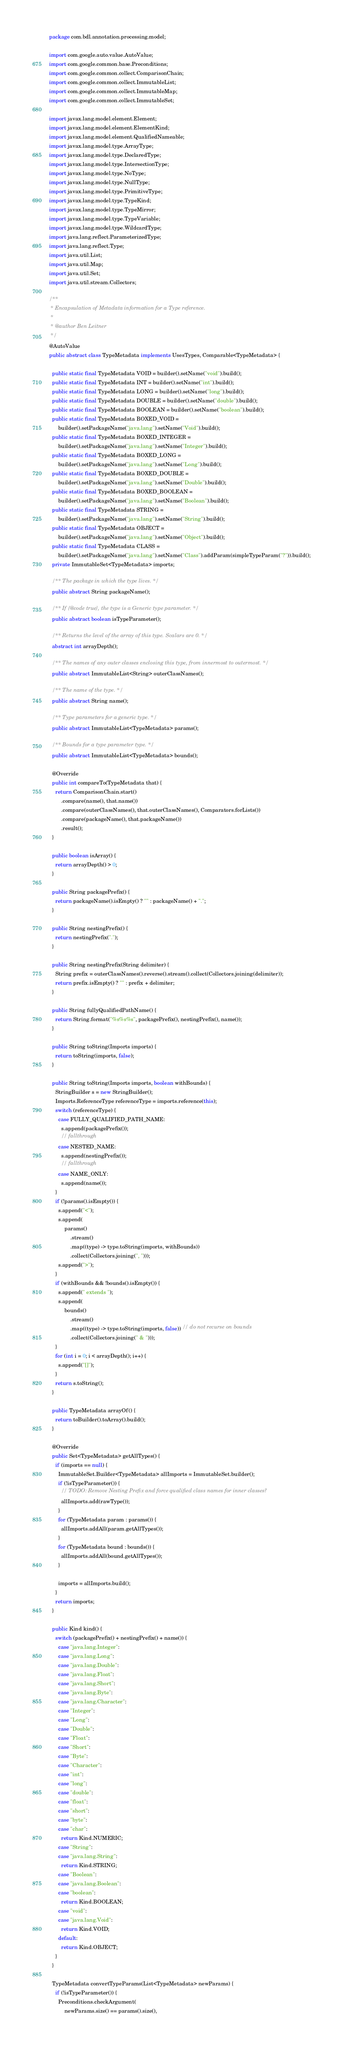Convert code to text. <code><loc_0><loc_0><loc_500><loc_500><_Java_>package com.bdl.annotation.processing.model;

import com.google.auto.value.AutoValue;
import com.google.common.base.Preconditions;
import com.google.common.collect.ComparisonChain;
import com.google.common.collect.ImmutableList;
import com.google.common.collect.ImmutableMap;
import com.google.common.collect.ImmutableSet;

import javax.lang.model.element.Element;
import javax.lang.model.element.ElementKind;
import javax.lang.model.element.QualifiedNameable;
import javax.lang.model.type.ArrayType;
import javax.lang.model.type.DeclaredType;
import javax.lang.model.type.IntersectionType;
import javax.lang.model.type.NoType;
import javax.lang.model.type.NullType;
import javax.lang.model.type.PrimitiveType;
import javax.lang.model.type.TypeKind;
import javax.lang.model.type.TypeMirror;
import javax.lang.model.type.TypeVariable;
import javax.lang.model.type.WildcardType;
import java.lang.reflect.ParameterizedType;
import java.lang.reflect.Type;
import java.util.List;
import java.util.Map;
import java.util.Set;
import java.util.stream.Collectors;

/**
 * Encapsulation of Metadata information for a Type reference.
 *
 * @author Ben Leitner
 */
@AutoValue
public abstract class TypeMetadata implements UsesTypes, Comparable<TypeMetadata> {

  public static final TypeMetadata VOID = builder().setName("void").build();
  public static final TypeMetadata INT = builder().setName("int").build();
  public static final TypeMetadata LONG = builder().setName("long").build();
  public static final TypeMetadata DOUBLE = builder().setName("double").build();
  public static final TypeMetadata BOOLEAN = builder().setName("boolean").build();
  public static final TypeMetadata BOXED_VOID =
      builder().setPackageName("java.lang").setName("Void").build();
  public static final TypeMetadata BOXED_INTEGER =
      builder().setPackageName("java.lang").setName("Integer").build();
  public static final TypeMetadata BOXED_LONG =
      builder().setPackageName("java.lang").setName("Long").build();
  public static final TypeMetadata BOXED_DOUBLE =
      builder().setPackageName("java.lang").setName("Double").build();
  public static final TypeMetadata BOXED_BOOLEAN =
      builder().setPackageName("java.lang").setName("Boolean").build();
  public static final TypeMetadata STRING =
      builder().setPackageName("java.lang").setName("String").build();
  public static final TypeMetadata OBJECT =
      builder().setPackageName("java.lang").setName("Object").build();
  public static final TypeMetadata CLASS =
      builder().setPackageName("java.lang").setName("Class").addParam(simpleTypeParam("?")).build();
  private ImmutableSet<TypeMetadata> imports;

  /** The package in which the type lives. */
  public abstract String packageName();

  /** If {@code true}, the type is a Generic type parameter. */
  public abstract boolean isTypeParameter();

  /** Returns the level of the array of this type. Scalars are 0. */
  abstract int arrayDepth();

  /** The names of any outer classes enclosing this type, from innermost to outermost. */
  public abstract ImmutableList<String> outerClassNames();

  /** The name of the type. */
  public abstract String name();

  /** Type parameters for a generic type. */
  public abstract ImmutableList<TypeMetadata> params();

  /** Bounds for a type parameter type. */
  public abstract ImmutableList<TypeMetadata> bounds();

  @Override
  public int compareTo(TypeMetadata that) {
    return ComparisonChain.start()
        .compare(name(), that.name())
        .compare(outerClassNames(), that.outerClassNames(), Comparators.forLists())
        .compare(packageName(), that.packageName())
        .result();
  }

  public boolean isArray() {
    return arrayDepth() > 0;
  }

  public String packagePrefix() {
    return packageName().isEmpty() ? "" : packageName() + ".";
  }

  public String nestingPrefix() {
    return nestingPrefix(".");
  }

  public String nestingPrefix(String delimiter) {
    String prefix = outerClassNames().reverse().stream().collect(Collectors.joining(delimiter));
    return prefix.isEmpty() ? "" : prefix + delimiter;
  }

  public String fullyQualifiedPathName() {
    return String.format("%s%s%s", packagePrefix(), nestingPrefix(), name());
  }

  public String toString(Imports imports) {
    return toString(imports, false);
  }

  public String toString(Imports imports, boolean withBounds) {
    StringBuilder s = new StringBuilder();
    Imports.ReferenceType referenceType = imports.reference(this);
    switch (referenceType) {
      case FULLY_QUALIFIED_PATH_NAME:
        s.append(packagePrefix());
        // fallthrough
      case NESTED_NAME:
        s.append(nestingPrefix());
        // fallthrough
      case NAME_ONLY:
        s.append(name());
    }
    if (!params().isEmpty()) {
      s.append("<");
      s.append(
          params()
              .stream()
              .map((type) -> type.toString(imports, withBounds))
              .collect(Collectors.joining(", ")));
      s.append(">");
    }
    if (withBounds && !bounds().isEmpty()) {
      s.append(" extends ");
      s.append(
          bounds()
              .stream()
              .map((type) -> type.toString(imports, false)) // do not recurse on bounds
              .collect(Collectors.joining(" & ")));
    }
    for (int i = 0; i < arrayDepth(); i++) {
      s.append("[]");
    }
    return s.toString();
  }

  public TypeMetadata arrayOf() {
    return toBuilder().toArray().build();
  }

  @Override
  public Set<TypeMetadata> getAllTypes() {
    if (imports == null) {
      ImmutableSet.Builder<TypeMetadata> allImports = ImmutableSet.builder();
      if (!isTypeParameter()) {
        // TODO: Remove Nesting Prefix and force qualified class names for inner classes?
        allImports.add(rawType());
      }
      for (TypeMetadata param : params()) {
        allImports.addAll(param.getAllTypes());
      }
      for (TypeMetadata bound : bounds()) {
        allImports.addAll(bound.getAllTypes());
      }

      imports = allImports.build();
    }
    return imports;
  }

  public Kind kind() {
    switch (packagePrefix() + nestingPrefix() + name()) {
      case "java.lang.Integer":
      case "java.lang.Long":
      case "java.lang.Double":
      case "java.lang.Float":
      case "java.lang.Short":
      case "java.lang.Byte":
      case "java.lang.Character":
      case "Integer":
      case "Long":
      case "Double":
      case "Float":
      case "Short":
      case "Byte":
      case "Character":
      case "int":
      case "long":
      case "double":
      case "float":
      case "short":
      case "byte":
      case "char":
        return Kind.NUMERIC;
      case "String":
      case "java.lang.String":
        return Kind.STRING;
      case "Boolean":
      case "java.lang.Boolean":
      case "boolean":
        return Kind.BOOLEAN;
      case "void":
      case "java.lang.Void":
        return Kind.VOID;
      default:
        return Kind.OBJECT;
    }
  }

  TypeMetadata convertTypeParams(List<TypeMetadata> newParams) {
    if (!isTypeParameter()) {
      Preconditions.checkArgument(
          newParams.size() == params().size(),</code> 